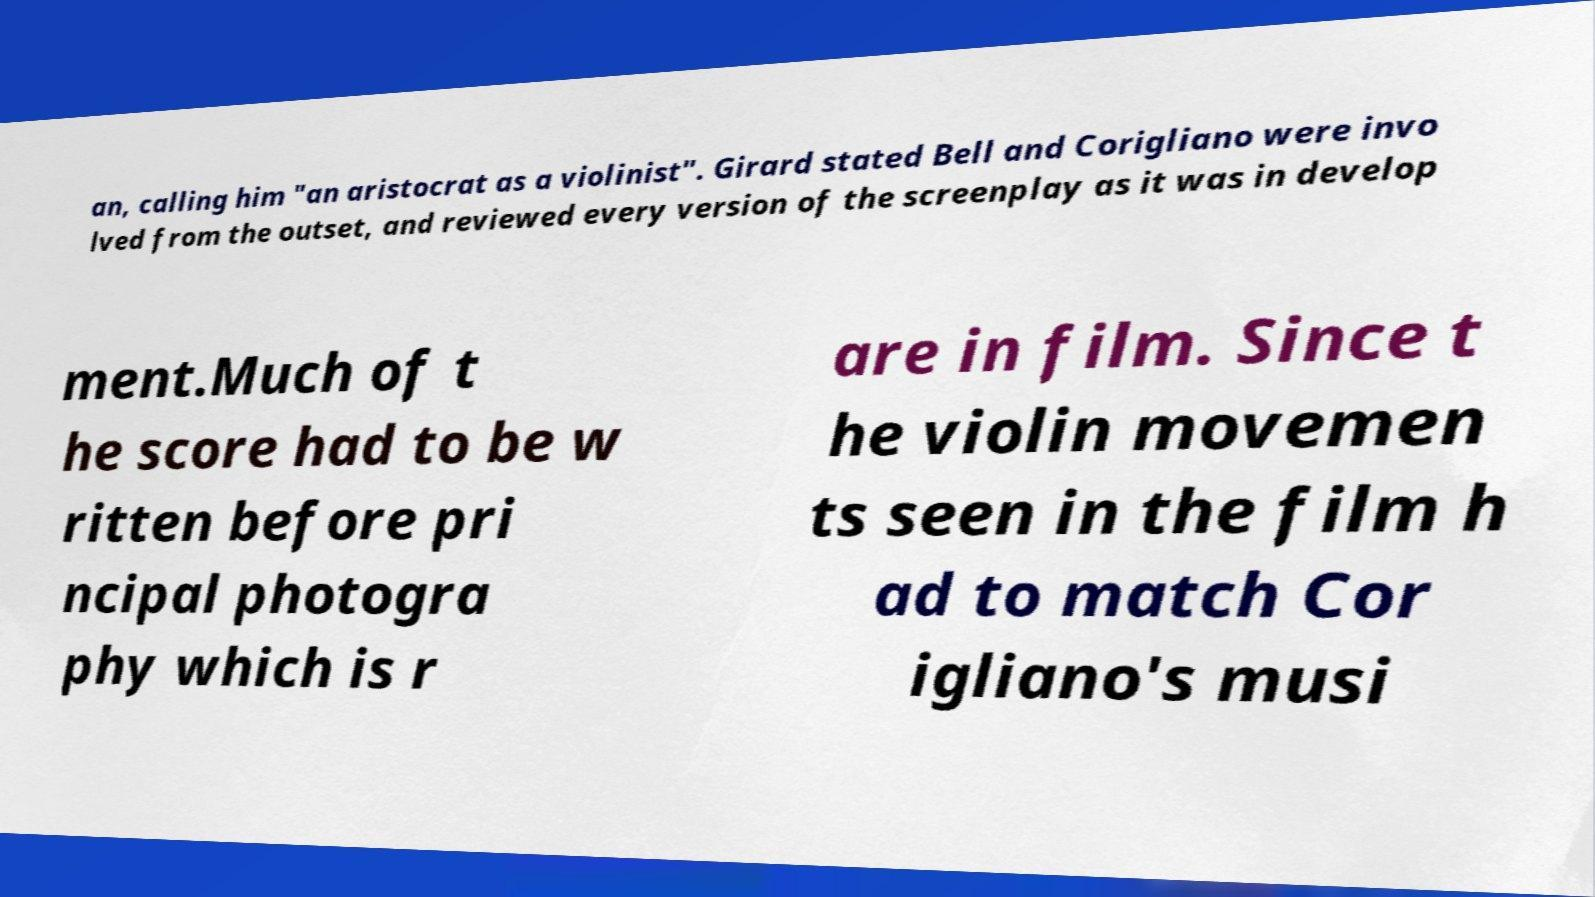Can you read and provide the text displayed in the image?This photo seems to have some interesting text. Can you extract and type it out for me? an, calling him "an aristocrat as a violinist". Girard stated Bell and Corigliano were invo lved from the outset, and reviewed every version of the screenplay as it was in develop ment.Much of t he score had to be w ritten before pri ncipal photogra phy which is r are in film. Since t he violin movemen ts seen in the film h ad to match Cor igliano's musi 